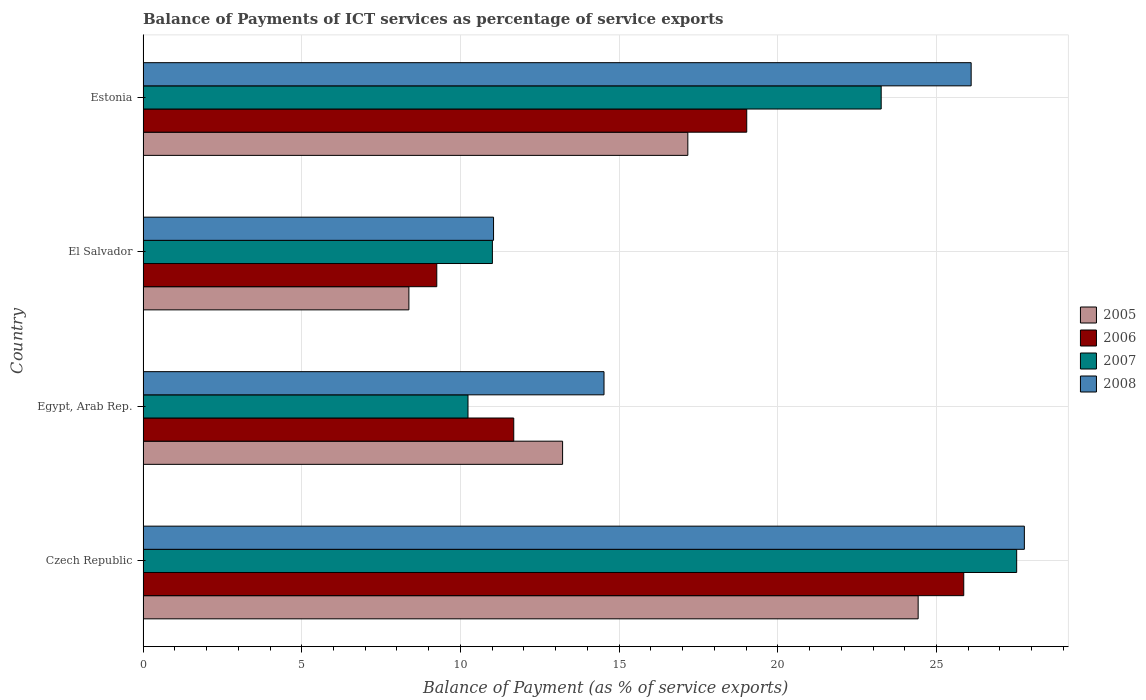How many groups of bars are there?
Ensure brevity in your answer.  4. Are the number of bars on each tick of the Y-axis equal?
Provide a succinct answer. Yes. What is the label of the 3rd group of bars from the top?
Offer a very short reply. Egypt, Arab Rep. What is the balance of payments of ICT services in 2008 in Estonia?
Keep it short and to the point. 26.09. Across all countries, what is the maximum balance of payments of ICT services in 2005?
Give a very brief answer. 24.42. Across all countries, what is the minimum balance of payments of ICT services in 2008?
Offer a very short reply. 11.04. In which country was the balance of payments of ICT services in 2005 maximum?
Offer a very short reply. Czech Republic. In which country was the balance of payments of ICT services in 2007 minimum?
Your response must be concise. Egypt, Arab Rep. What is the total balance of payments of ICT services in 2006 in the graph?
Your answer should be very brief. 65.82. What is the difference between the balance of payments of ICT services in 2006 in Egypt, Arab Rep. and that in Estonia?
Your response must be concise. -7.34. What is the difference between the balance of payments of ICT services in 2007 in Egypt, Arab Rep. and the balance of payments of ICT services in 2005 in Estonia?
Your answer should be compact. -6.93. What is the average balance of payments of ICT services in 2007 per country?
Provide a short and direct response. 18.01. What is the difference between the balance of payments of ICT services in 2005 and balance of payments of ICT services in 2008 in El Salvador?
Give a very brief answer. -2.67. In how many countries, is the balance of payments of ICT services in 2006 greater than 26 %?
Your answer should be very brief. 0. What is the ratio of the balance of payments of ICT services in 2007 in Czech Republic to that in El Salvador?
Your response must be concise. 2.5. Is the balance of payments of ICT services in 2006 in El Salvador less than that in Estonia?
Make the answer very short. Yes. Is the difference between the balance of payments of ICT services in 2005 in Czech Republic and El Salvador greater than the difference between the balance of payments of ICT services in 2008 in Czech Republic and El Salvador?
Keep it short and to the point. No. What is the difference between the highest and the second highest balance of payments of ICT services in 2005?
Provide a succinct answer. 7.26. What is the difference between the highest and the lowest balance of payments of ICT services in 2005?
Provide a succinct answer. 16.05. In how many countries, is the balance of payments of ICT services in 2007 greater than the average balance of payments of ICT services in 2007 taken over all countries?
Your response must be concise. 2. What does the 4th bar from the top in Czech Republic represents?
Offer a terse response. 2005. What does the 4th bar from the bottom in El Salvador represents?
Provide a short and direct response. 2008. How many countries are there in the graph?
Keep it short and to the point. 4. What is the difference between two consecutive major ticks on the X-axis?
Your answer should be very brief. 5. Does the graph contain any zero values?
Keep it short and to the point. No. Where does the legend appear in the graph?
Provide a succinct answer. Center right. How many legend labels are there?
Your response must be concise. 4. How are the legend labels stacked?
Provide a short and direct response. Vertical. What is the title of the graph?
Keep it short and to the point. Balance of Payments of ICT services as percentage of service exports. What is the label or title of the X-axis?
Give a very brief answer. Balance of Payment (as % of service exports). What is the Balance of Payment (as % of service exports) of 2005 in Czech Republic?
Give a very brief answer. 24.42. What is the Balance of Payment (as % of service exports) of 2006 in Czech Republic?
Make the answer very short. 25.86. What is the Balance of Payment (as % of service exports) of 2007 in Czech Republic?
Your response must be concise. 27.53. What is the Balance of Payment (as % of service exports) of 2008 in Czech Republic?
Your answer should be very brief. 27.77. What is the Balance of Payment (as % of service exports) in 2005 in Egypt, Arab Rep.?
Make the answer very short. 13.22. What is the Balance of Payment (as % of service exports) in 2006 in Egypt, Arab Rep.?
Your answer should be compact. 11.68. What is the Balance of Payment (as % of service exports) of 2007 in Egypt, Arab Rep.?
Your response must be concise. 10.24. What is the Balance of Payment (as % of service exports) of 2008 in Egypt, Arab Rep.?
Your answer should be very brief. 14.52. What is the Balance of Payment (as % of service exports) in 2005 in El Salvador?
Offer a terse response. 8.38. What is the Balance of Payment (as % of service exports) of 2006 in El Salvador?
Give a very brief answer. 9.25. What is the Balance of Payment (as % of service exports) in 2007 in El Salvador?
Your answer should be very brief. 11.01. What is the Balance of Payment (as % of service exports) in 2008 in El Salvador?
Your answer should be compact. 11.04. What is the Balance of Payment (as % of service exports) in 2005 in Estonia?
Keep it short and to the point. 17.16. What is the Balance of Payment (as % of service exports) of 2006 in Estonia?
Provide a short and direct response. 19.02. What is the Balance of Payment (as % of service exports) of 2007 in Estonia?
Provide a succinct answer. 23.26. What is the Balance of Payment (as % of service exports) in 2008 in Estonia?
Provide a short and direct response. 26.09. Across all countries, what is the maximum Balance of Payment (as % of service exports) of 2005?
Give a very brief answer. 24.42. Across all countries, what is the maximum Balance of Payment (as % of service exports) of 2006?
Offer a very short reply. 25.86. Across all countries, what is the maximum Balance of Payment (as % of service exports) in 2007?
Ensure brevity in your answer.  27.53. Across all countries, what is the maximum Balance of Payment (as % of service exports) in 2008?
Keep it short and to the point. 27.77. Across all countries, what is the minimum Balance of Payment (as % of service exports) in 2005?
Keep it short and to the point. 8.38. Across all countries, what is the minimum Balance of Payment (as % of service exports) of 2006?
Provide a succinct answer. 9.25. Across all countries, what is the minimum Balance of Payment (as % of service exports) of 2007?
Make the answer very short. 10.24. Across all countries, what is the minimum Balance of Payment (as % of service exports) of 2008?
Your answer should be very brief. 11.04. What is the total Balance of Payment (as % of service exports) of 2005 in the graph?
Make the answer very short. 63.18. What is the total Balance of Payment (as % of service exports) of 2006 in the graph?
Offer a very short reply. 65.82. What is the total Balance of Payment (as % of service exports) of 2007 in the graph?
Keep it short and to the point. 72.03. What is the total Balance of Payment (as % of service exports) in 2008 in the graph?
Your response must be concise. 79.43. What is the difference between the Balance of Payment (as % of service exports) of 2005 in Czech Republic and that in Egypt, Arab Rep.?
Your answer should be compact. 11.2. What is the difference between the Balance of Payment (as % of service exports) of 2006 in Czech Republic and that in Egypt, Arab Rep.?
Offer a terse response. 14.18. What is the difference between the Balance of Payment (as % of service exports) in 2007 in Czech Republic and that in Egypt, Arab Rep.?
Ensure brevity in your answer.  17.29. What is the difference between the Balance of Payment (as % of service exports) of 2008 in Czech Republic and that in Egypt, Arab Rep.?
Keep it short and to the point. 13.24. What is the difference between the Balance of Payment (as % of service exports) in 2005 in Czech Republic and that in El Salvador?
Ensure brevity in your answer.  16.05. What is the difference between the Balance of Payment (as % of service exports) of 2006 in Czech Republic and that in El Salvador?
Provide a succinct answer. 16.6. What is the difference between the Balance of Payment (as % of service exports) in 2007 in Czech Republic and that in El Salvador?
Your answer should be very brief. 16.52. What is the difference between the Balance of Payment (as % of service exports) in 2008 in Czech Republic and that in El Salvador?
Your answer should be very brief. 16.73. What is the difference between the Balance of Payment (as % of service exports) in 2005 in Czech Republic and that in Estonia?
Your answer should be compact. 7.26. What is the difference between the Balance of Payment (as % of service exports) in 2006 in Czech Republic and that in Estonia?
Give a very brief answer. 6.84. What is the difference between the Balance of Payment (as % of service exports) of 2007 in Czech Republic and that in Estonia?
Offer a very short reply. 4.27. What is the difference between the Balance of Payment (as % of service exports) in 2008 in Czech Republic and that in Estonia?
Keep it short and to the point. 1.68. What is the difference between the Balance of Payment (as % of service exports) of 2005 in Egypt, Arab Rep. and that in El Salvador?
Offer a terse response. 4.84. What is the difference between the Balance of Payment (as % of service exports) of 2006 in Egypt, Arab Rep. and that in El Salvador?
Ensure brevity in your answer.  2.43. What is the difference between the Balance of Payment (as % of service exports) in 2007 in Egypt, Arab Rep. and that in El Salvador?
Offer a terse response. -0.77. What is the difference between the Balance of Payment (as % of service exports) of 2008 in Egypt, Arab Rep. and that in El Salvador?
Offer a terse response. 3.48. What is the difference between the Balance of Payment (as % of service exports) in 2005 in Egypt, Arab Rep. and that in Estonia?
Your response must be concise. -3.95. What is the difference between the Balance of Payment (as % of service exports) in 2006 in Egypt, Arab Rep. and that in Estonia?
Your response must be concise. -7.34. What is the difference between the Balance of Payment (as % of service exports) in 2007 in Egypt, Arab Rep. and that in Estonia?
Your response must be concise. -13.02. What is the difference between the Balance of Payment (as % of service exports) of 2008 in Egypt, Arab Rep. and that in Estonia?
Your answer should be compact. -11.57. What is the difference between the Balance of Payment (as % of service exports) in 2005 in El Salvador and that in Estonia?
Your answer should be very brief. -8.79. What is the difference between the Balance of Payment (as % of service exports) of 2006 in El Salvador and that in Estonia?
Provide a short and direct response. -9.77. What is the difference between the Balance of Payment (as % of service exports) in 2007 in El Salvador and that in Estonia?
Offer a terse response. -12.25. What is the difference between the Balance of Payment (as % of service exports) in 2008 in El Salvador and that in Estonia?
Offer a very short reply. -15.05. What is the difference between the Balance of Payment (as % of service exports) of 2005 in Czech Republic and the Balance of Payment (as % of service exports) of 2006 in Egypt, Arab Rep.?
Ensure brevity in your answer.  12.74. What is the difference between the Balance of Payment (as % of service exports) of 2005 in Czech Republic and the Balance of Payment (as % of service exports) of 2007 in Egypt, Arab Rep.?
Give a very brief answer. 14.18. What is the difference between the Balance of Payment (as % of service exports) in 2005 in Czech Republic and the Balance of Payment (as % of service exports) in 2008 in Egypt, Arab Rep.?
Provide a succinct answer. 9.9. What is the difference between the Balance of Payment (as % of service exports) of 2006 in Czech Republic and the Balance of Payment (as % of service exports) of 2007 in Egypt, Arab Rep.?
Your answer should be very brief. 15.62. What is the difference between the Balance of Payment (as % of service exports) of 2006 in Czech Republic and the Balance of Payment (as % of service exports) of 2008 in Egypt, Arab Rep.?
Provide a succinct answer. 11.34. What is the difference between the Balance of Payment (as % of service exports) in 2007 in Czech Republic and the Balance of Payment (as % of service exports) in 2008 in Egypt, Arab Rep.?
Offer a very short reply. 13. What is the difference between the Balance of Payment (as % of service exports) of 2005 in Czech Republic and the Balance of Payment (as % of service exports) of 2006 in El Salvador?
Make the answer very short. 15.17. What is the difference between the Balance of Payment (as % of service exports) of 2005 in Czech Republic and the Balance of Payment (as % of service exports) of 2007 in El Salvador?
Make the answer very short. 13.42. What is the difference between the Balance of Payment (as % of service exports) in 2005 in Czech Republic and the Balance of Payment (as % of service exports) in 2008 in El Salvador?
Offer a terse response. 13.38. What is the difference between the Balance of Payment (as % of service exports) of 2006 in Czech Republic and the Balance of Payment (as % of service exports) of 2007 in El Salvador?
Give a very brief answer. 14.85. What is the difference between the Balance of Payment (as % of service exports) of 2006 in Czech Republic and the Balance of Payment (as % of service exports) of 2008 in El Salvador?
Make the answer very short. 14.82. What is the difference between the Balance of Payment (as % of service exports) in 2007 in Czech Republic and the Balance of Payment (as % of service exports) in 2008 in El Salvador?
Offer a terse response. 16.48. What is the difference between the Balance of Payment (as % of service exports) of 2005 in Czech Republic and the Balance of Payment (as % of service exports) of 2006 in Estonia?
Your answer should be very brief. 5.4. What is the difference between the Balance of Payment (as % of service exports) of 2005 in Czech Republic and the Balance of Payment (as % of service exports) of 2007 in Estonia?
Your response must be concise. 1.16. What is the difference between the Balance of Payment (as % of service exports) in 2005 in Czech Republic and the Balance of Payment (as % of service exports) in 2008 in Estonia?
Your answer should be compact. -1.67. What is the difference between the Balance of Payment (as % of service exports) in 2006 in Czech Republic and the Balance of Payment (as % of service exports) in 2007 in Estonia?
Provide a succinct answer. 2.6. What is the difference between the Balance of Payment (as % of service exports) in 2006 in Czech Republic and the Balance of Payment (as % of service exports) in 2008 in Estonia?
Your answer should be compact. -0.23. What is the difference between the Balance of Payment (as % of service exports) of 2007 in Czech Republic and the Balance of Payment (as % of service exports) of 2008 in Estonia?
Offer a very short reply. 1.43. What is the difference between the Balance of Payment (as % of service exports) of 2005 in Egypt, Arab Rep. and the Balance of Payment (as % of service exports) of 2006 in El Salvador?
Your response must be concise. 3.96. What is the difference between the Balance of Payment (as % of service exports) of 2005 in Egypt, Arab Rep. and the Balance of Payment (as % of service exports) of 2007 in El Salvador?
Ensure brevity in your answer.  2.21. What is the difference between the Balance of Payment (as % of service exports) of 2005 in Egypt, Arab Rep. and the Balance of Payment (as % of service exports) of 2008 in El Salvador?
Provide a succinct answer. 2.18. What is the difference between the Balance of Payment (as % of service exports) of 2006 in Egypt, Arab Rep. and the Balance of Payment (as % of service exports) of 2007 in El Salvador?
Keep it short and to the point. 0.67. What is the difference between the Balance of Payment (as % of service exports) of 2006 in Egypt, Arab Rep. and the Balance of Payment (as % of service exports) of 2008 in El Salvador?
Your response must be concise. 0.64. What is the difference between the Balance of Payment (as % of service exports) in 2007 in Egypt, Arab Rep. and the Balance of Payment (as % of service exports) in 2008 in El Salvador?
Offer a terse response. -0.8. What is the difference between the Balance of Payment (as % of service exports) in 2005 in Egypt, Arab Rep. and the Balance of Payment (as % of service exports) in 2006 in Estonia?
Make the answer very short. -5.8. What is the difference between the Balance of Payment (as % of service exports) in 2005 in Egypt, Arab Rep. and the Balance of Payment (as % of service exports) in 2007 in Estonia?
Provide a succinct answer. -10.04. What is the difference between the Balance of Payment (as % of service exports) of 2005 in Egypt, Arab Rep. and the Balance of Payment (as % of service exports) of 2008 in Estonia?
Make the answer very short. -12.87. What is the difference between the Balance of Payment (as % of service exports) of 2006 in Egypt, Arab Rep. and the Balance of Payment (as % of service exports) of 2007 in Estonia?
Ensure brevity in your answer.  -11.58. What is the difference between the Balance of Payment (as % of service exports) in 2006 in Egypt, Arab Rep. and the Balance of Payment (as % of service exports) in 2008 in Estonia?
Your answer should be compact. -14.41. What is the difference between the Balance of Payment (as % of service exports) in 2007 in Egypt, Arab Rep. and the Balance of Payment (as % of service exports) in 2008 in Estonia?
Your answer should be compact. -15.85. What is the difference between the Balance of Payment (as % of service exports) of 2005 in El Salvador and the Balance of Payment (as % of service exports) of 2006 in Estonia?
Give a very brief answer. -10.65. What is the difference between the Balance of Payment (as % of service exports) in 2005 in El Salvador and the Balance of Payment (as % of service exports) in 2007 in Estonia?
Your response must be concise. -14.88. What is the difference between the Balance of Payment (as % of service exports) of 2005 in El Salvador and the Balance of Payment (as % of service exports) of 2008 in Estonia?
Give a very brief answer. -17.72. What is the difference between the Balance of Payment (as % of service exports) in 2006 in El Salvador and the Balance of Payment (as % of service exports) in 2007 in Estonia?
Offer a very short reply. -14. What is the difference between the Balance of Payment (as % of service exports) in 2006 in El Salvador and the Balance of Payment (as % of service exports) in 2008 in Estonia?
Offer a terse response. -16.84. What is the difference between the Balance of Payment (as % of service exports) of 2007 in El Salvador and the Balance of Payment (as % of service exports) of 2008 in Estonia?
Your response must be concise. -15.09. What is the average Balance of Payment (as % of service exports) of 2005 per country?
Offer a terse response. 15.8. What is the average Balance of Payment (as % of service exports) of 2006 per country?
Keep it short and to the point. 16.45. What is the average Balance of Payment (as % of service exports) of 2007 per country?
Ensure brevity in your answer.  18.01. What is the average Balance of Payment (as % of service exports) of 2008 per country?
Give a very brief answer. 19.86. What is the difference between the Balance of Payment (as % of service exports) in 2005 and Balance of Payment (as % of service exports) in 2006 in Czech Republic?
Your answer should be very brief. -1.44. What is the difference between the Balance of Payment (as % of service exports) in 2005 and Balance of Payment (as % of service exports) in 2007 in Czech Republic?
Offer a very short reply. -3.1. What is the difference between the Balance of Payment (as % of service exports) of 2005 and Balance of Payment (as % of service exports) of 2008 in Czech Republic?
Ensure brevity in your answer.  -3.35. What is the difference between the Balance of Payment (as % of service exports) of 2006 and Balance of Payment (as % of service exports) of 2007 in Czech Republic?
Keep it short and to the point. -1.67. What is the difference between the Balance of Payment (as % of service exports) in 2006 and Balance of Payment (as % of service exports) in 2008 in Czech Republic?
Keep it short and to the point. -1.91. What is the difference between the Balance of Payment (as % of service exports) in 2007 and Balance of Payment (as % of service exports) in 2008 in Czech Republic?
Offer a very short reply. -0.24. What is the difference between the Balance of Payment (as % of service exports) of 2005 and Balance of Payment (as % of service exports) of 2006 in Egypt, Arab Rep.?
Give a very brief answer. 1.54. What is the difference between the Balance of Payment (as % of service exports) of 2005 and Balance of Payment (as % of service exports) of 2007 in Egypt, Arab Rep.?
Your response must be concise. 2.98. What is the difference between the Balance of Payment (as % of service exports) of 2005 and Balance of Payment (as % of service exports) of 2008 in Egypt, Arab Rep.?
Offer a very short reply. -1.3. What is the difference between the Balance of Payment (as % of service exports) in 2006 and Balance of Payment (as % of service exports) in 2007 in Egypt, Arab Rep.?
Ensure brevity in your answer.  1.44. What is the difference between the Balance of Payment (as % of service exports) of 2006 and Balance of Payment (as % of service exports) of 2008 in Egypt, Arab Rep.?
Give a very brief answer. -2.84. What is the difference between the Balance of Payment (as % of service exports) in 2007 and Balance of Payment (as % of service exports) in 2008 in Egypt, Arab Rep.?
Ensure brevity in your answer.  -4.29. What is the difference between the Balance of Payment (as % of service exports) of 2005 and Balance of Payment (as % of service exports) of 2006 in El Salvador?
Keep it short and to the point. -0.88. What is the difference between the Balance of Payment (as % of service exports) of 2005 and Balance of Payment (as % of service exports) of 2007 in El Salvador?
Make the answer very short. -2.63. What is the difference between the Balance of Payment (as % of service exports) in 2005 and Balance of Payment (as % of service exports) in 2008 in El Salvador?
Make the answer very short. -2.67. What is the difference between the Balance of Payment (as % of service exports) of 2006 and Balance of Payment (as % of service exports) of 2007 in El Salvador?
Provide a short and direct response. -1.75. What is the difference between the Balance of Payment (as % of service exports) of 2006 and Balance of Payment (as % of service exports) of 2008 in El Salvador?
Your answer should be compact. -1.79. What is the difference between the Balance of Payment (as % of service exports) in 2007 and Balance of Payment (as % of service exports) in 2008 in El Salvador?
Make the answer very short. -0.04. What is the difference between the Balance of Payment (as % of service exports) of 2005 and Balance of Payment (as % of service exports) of 2006 in Estonia?
Provide a succinct answer. -1.86. What is the difference between the Balance of Payment (as % of service exports) in 2005 and Balance of Payment (as % of service exports) in 2007 in Estonia?
Offer a very short reply. -6.09. What is the difference between the Balance of Payment (as % of service exports) of 2005 and Balance of Payment (as % of service exports) of 2008 in Estonia?
Give a very brief answer. -8.93. What is the difference between the Balance of Payment (as % of service exports) of 2006 and Balance of Payment (as % of service exports) of 2007 in Estonia?
Provide a succinct answer. -4.24. What is the difference between the Balance of Payment (as % of service exports) in 2006 and Balance of Payment (as % of service exports) in 2008 in Estonia?
Make the answer very short. -7.07. What is the difference between the Balance of Payment (as % of service exports) of 2007 and Balance of Payment (as % of service exports) of 2008 in Estonia?
Your answer should be compact. -2.84. What is the ratio of the Balance of Payment (as % of service exports) in 2005 in Czech Republic to that in Egypt, Arab Rep.?
Your answer should be very brief. 1.85. What is the ratio of the Balance of Payment (as % of service exports) in 2006 in Czech Republic to that in Egypt, Arab Rep.?
Offer a very short reply. 2.21. What is the ratio of the Balance of Payment (as % of service exports) in 2007 in Czech Republic to that in Egypt, Arab Rep.?
Offer a very short reply. 2.69. What is the ratio of the Balance of Payment (as % of service exports) in 2008 in Czech Republic to that in Egypt, Arab Rep.?
Provide a succinct answer. 1.91. What is the ratio of the Balance of Payment (as % of service exports) in 2005 in Czech Republic to that in El Salvador?
Offer a very short reply. 2.92. What is the ratio of the Balance of Payment (as % of service exports) in 2006 in Czech Republic to that in El Salvador?
Provide a short and direct response. 2.79. What is the ratio of the Balance of Payment (as % of service exports) in 2007 in Czech Republic to that in El Salvador?
Your answer should be very brief. 2.5. What is the ratio of the Balance of Payment (as % of service exports) in 2008 in Czech Republic to that in El Salvador?
Give a very brief answer. 2.51. What is the ratio of the Balance of Payment (as % of service exports) in 2005 in Czech Republic to that in Estonia?
Give a very brief answer. 1.42. What is the ratio of the Balance of Payment (as % of service exports) of 2006 in Czech Republic to that in Estonia?
Your answer should be compact. 1.36. What is the ratio of the Balance of Payment (as % of service exports) of 2007 in Czech Republic to that in Estonia?
Keep it short and to the point. 1.18. What is the ratio of the Balance of Payment (as % of service exports) of 2008 in Czech Republic to that in Estonia?
Ensure brevity in your answer.  1.06. What is the ratio of the Balance of Payment (as % of service exports) of 2005 in Egypt, Arab Rep. to that in El Salvador?
Your answer should be very brief. 1.58. What is the ratio of the Balance of Payment (as % of service exports) of 2006 in Egypt, Arab Rep. to that in El Salvador?
Offer a terse response. 1.26. What is the ratio of the Balance of Payment (as % of service exports) in 2007 in Egypt, Arab Rep. to that in El Salvador?
Your answer should be compact. 0.93. What is the ratio of the Balance of Payment (as % of service exports) in 2008 in Egypt, Arab Rep. to that in El Salvador?
Give a very brief answer. 1.32. What is the ratio of the Balance of Payment (as % of service exports) in 2005 in Egypt, Arab Rep. to that in Estonia?
Your response must be concise. 0.77. What is the ratio of the Balance of Payment (as % of service exports) of 2006 in Egypt, Arab Rep. to that in Estonia?
Ensure brevity in your answer.  0.61. What is the ratio of the Balance of Payment (as % of service exports) of 2007 in Egypt, Arab Rep. to that in Estonia?
Give a very brief answer. 0.44. What is the ratio of the Balance of Payment (as % of service exports) of 2008 in Egypt, Arab Rep. to that in Estonia?
Your response must be concise. 0.56. What is the ratio of the Balance of Payment (as % of service exports) of 2005 in El Salvador to that in Estonia?
Make the answer very short. 0.49. What is the ratio of the Balance of Payment (as % of service exports) of 2006 in El Salvador to that in Estonia?
Your answer should be very brief. 0.49. What is the ratio of the Balance of Payment (as % of service exports) of 2007 in El Salvador to that in Estonia?
Give a very brief answer. 0.47. What is the ratio of the Balance of Payment (as % of service exports) of 2008 in El Salvador to that in Estonia?
Provide a short and direct response. 0.42. What is the difference between the highest and the second highest Balance of Payment (as % of service exports) of 2005?
Your answer should be very brief. 7.26. What is the difference between the highest and the second highest Balance of Payment (as % of service exports) in 2006?
Your answer should be very brief. 6.84. What is the difference between the highest and the second highest Balance of Payment (as % of service exports) in 2007?
Offer a very short reply. 4.27. What is the difference between the highest and the second highest Balance of Payment (as % of service exports) of 2008?
Offer a very short reply. 1.68. What is the difference between the highest and the lowest Balance of Payment (as % of service exports) of 2005?
Give a very brief answer. 16.05. What is the difference between the highest and the lowest Balance of Payment (as % of service exports) of 2006?
Make the answer very short. 16.6. What is the difference between the highest and the lowest Balance of Payment (as % of service exports) of 2007?
Offer a terse response. 17.29. What is the difference between the highest and the lowest Balance of Payment (as % of service exports) of 2008?
Your answer should be compact. 16.73. 